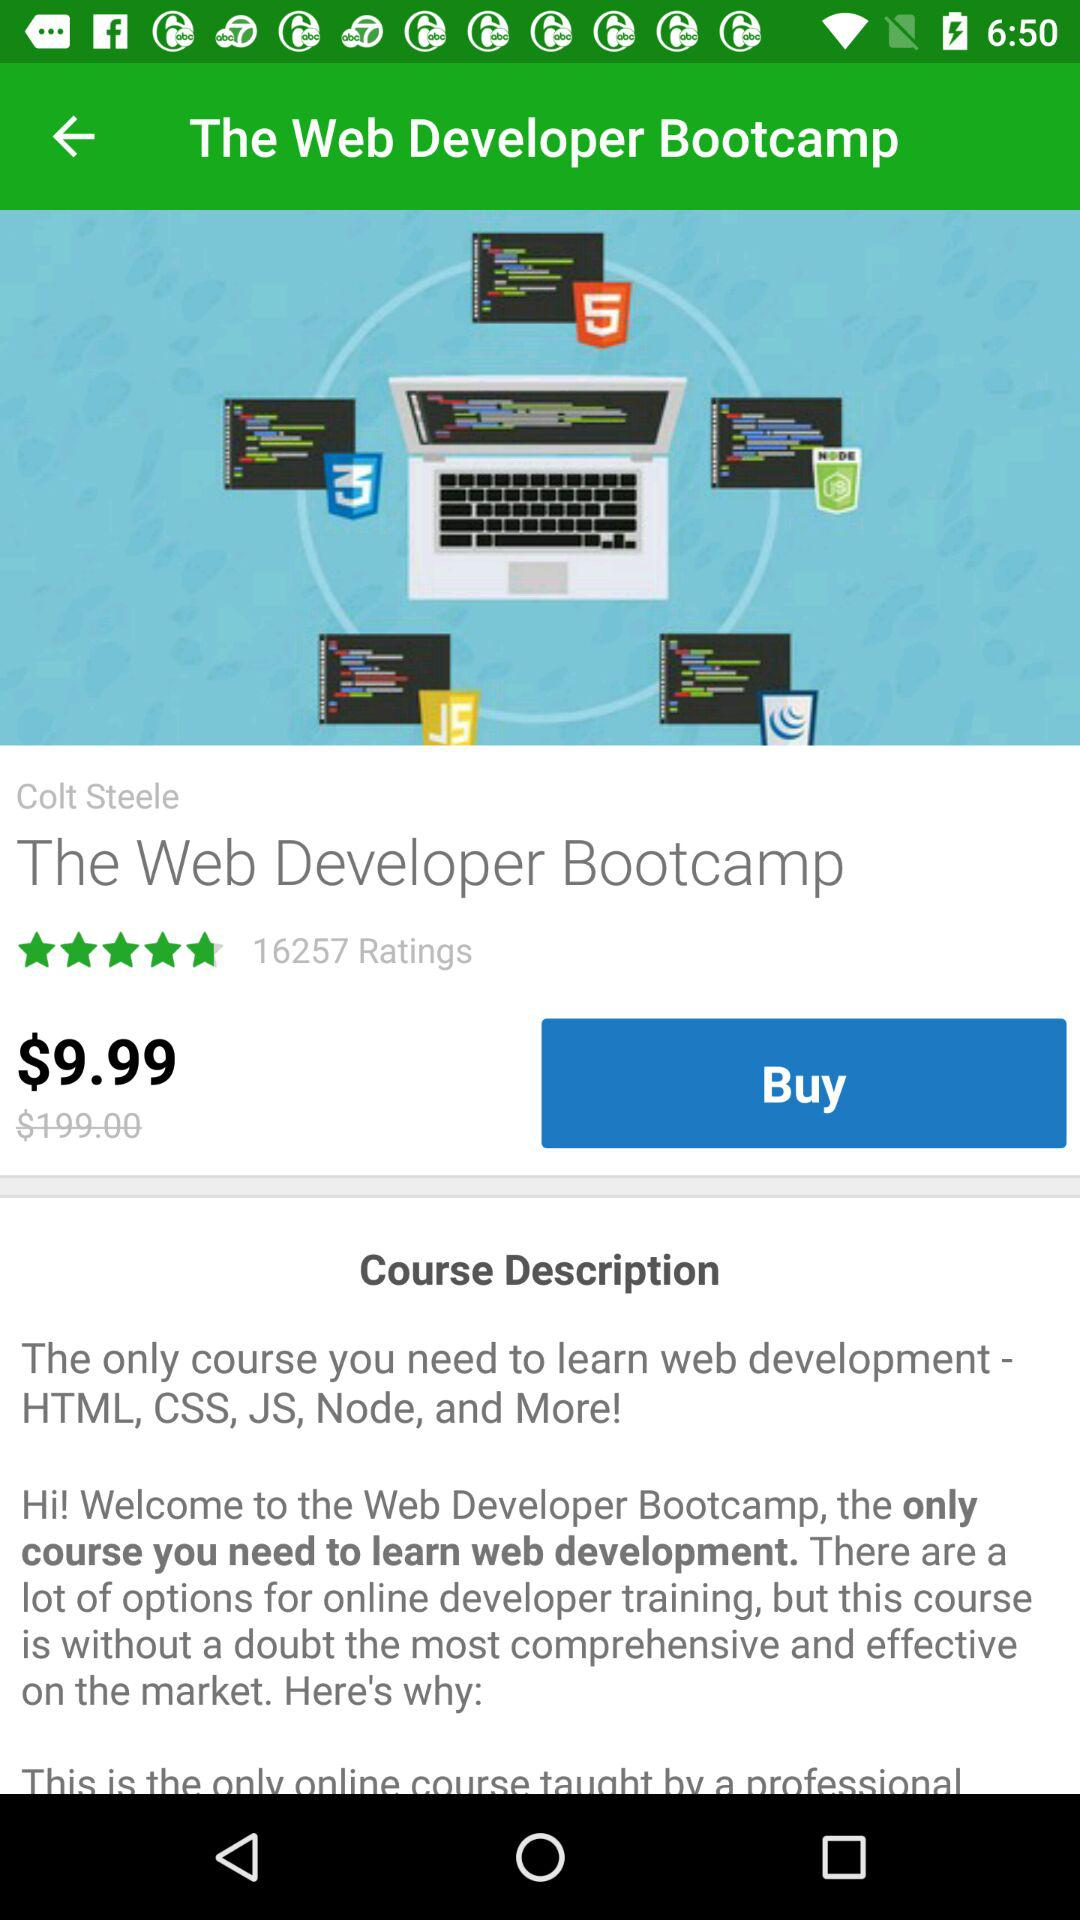What is the course description?
When the provided information is insufficient, respond with <no answer>. <no answer> 